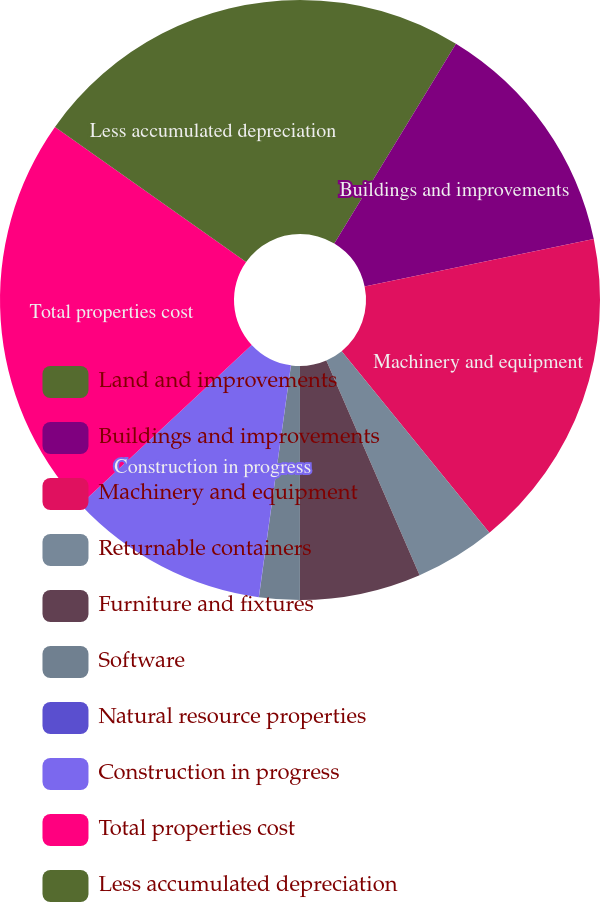<chart> <loc_0><loc_0><loc_500><loc_500><pie_chart><fcel>Land and improvements<fcel>Buildings and improvements<fcel>Machinery and equipment<fcel>Returnable containers<fcel>Furniture and fixtures<fcel>Software<fcel>Natural resource properties<fcel>Construction in progress<fcel>Total properties cost<fcel>Less accumulated depreciation<nl><fcel>8.7%<fcel>13.04%<fcel>17.38%<fcel>4.35%<fcel>6.53%<fcel>2.18%<fcel>0.01%<fcel>10.87%<fcel>21.72%<fcel>15.21%<nl></chart> 